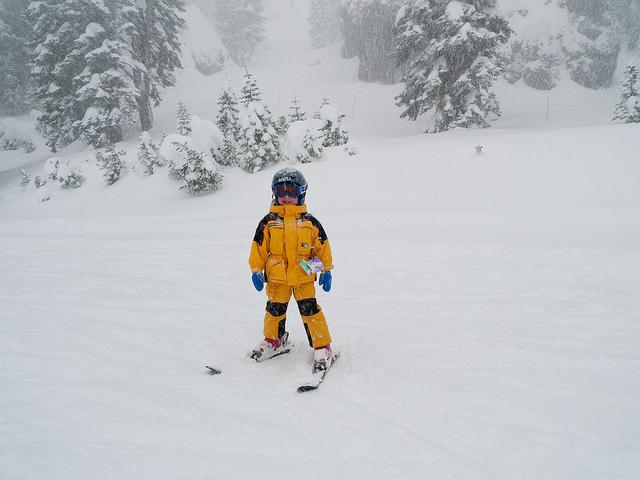Is the weather extreme?
Give a very brief answer. Yes. How many people in this photo?
Quick response, please. 1. Is this child posing for the photo?
Concise answer only. Yes. 